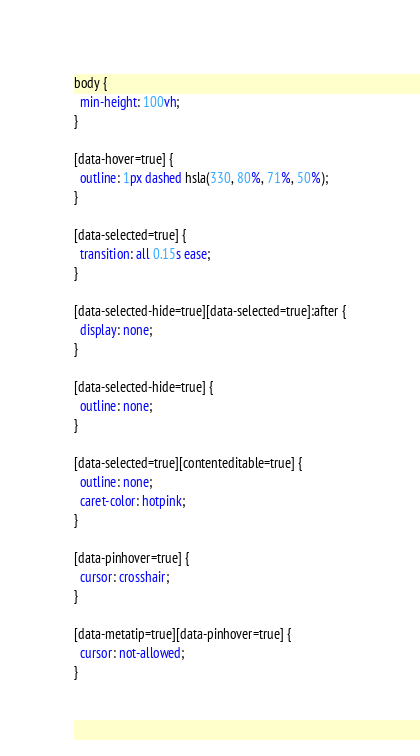<code> <loc_0><loc_0><loc_500><loc_500><_CSS_>body {
  min-height: 100vh;
}

[data-hover=true] {
  outline: 1px dashed hsla(330, 80%, 71%, 50%);
}

[data-selected=true] {
  transition: all 0.15s ease;
}

[data-selected-hide=true][data-selected=true]:after {
  display: none;
}

[data-selected-hide=true] {
  outline: none;
}

[data-selected=true][contenteditable=true] {
  outline: none;
  caret-color: hotpink;
}

[data-pinhover=true] {
  cursor: crosshair;
}

[data-metatip=true][data-pinhover=true] {
  cursor: not-allowed;
}
</code> 